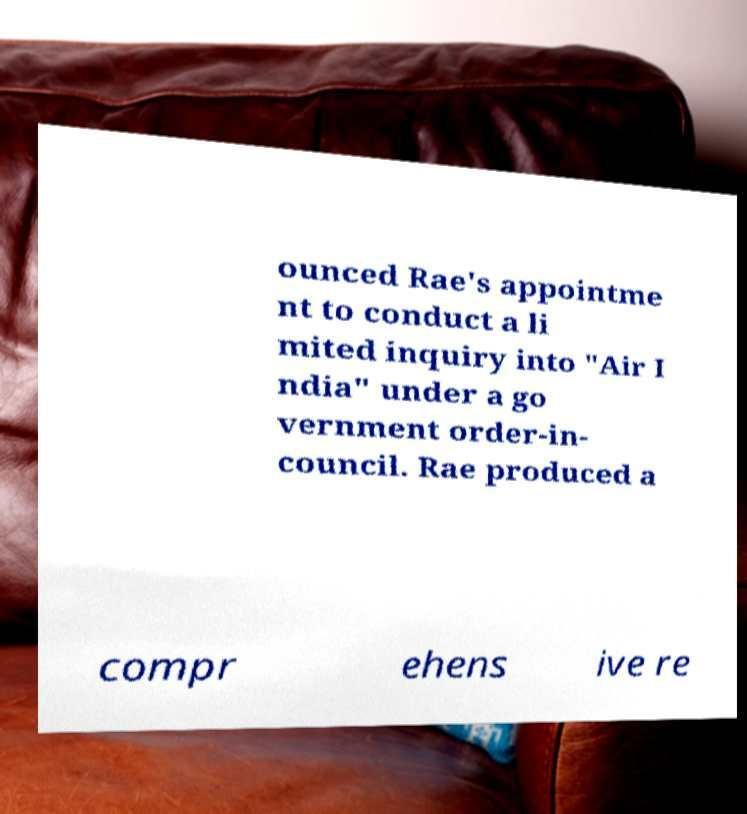Could you extract and type out the text from this image? ounced Rae's appointme nt to conduct a li mited inquiry into "Air I ndia" under a go vernment order-in- council. Rae produced a compr ehens ive re 